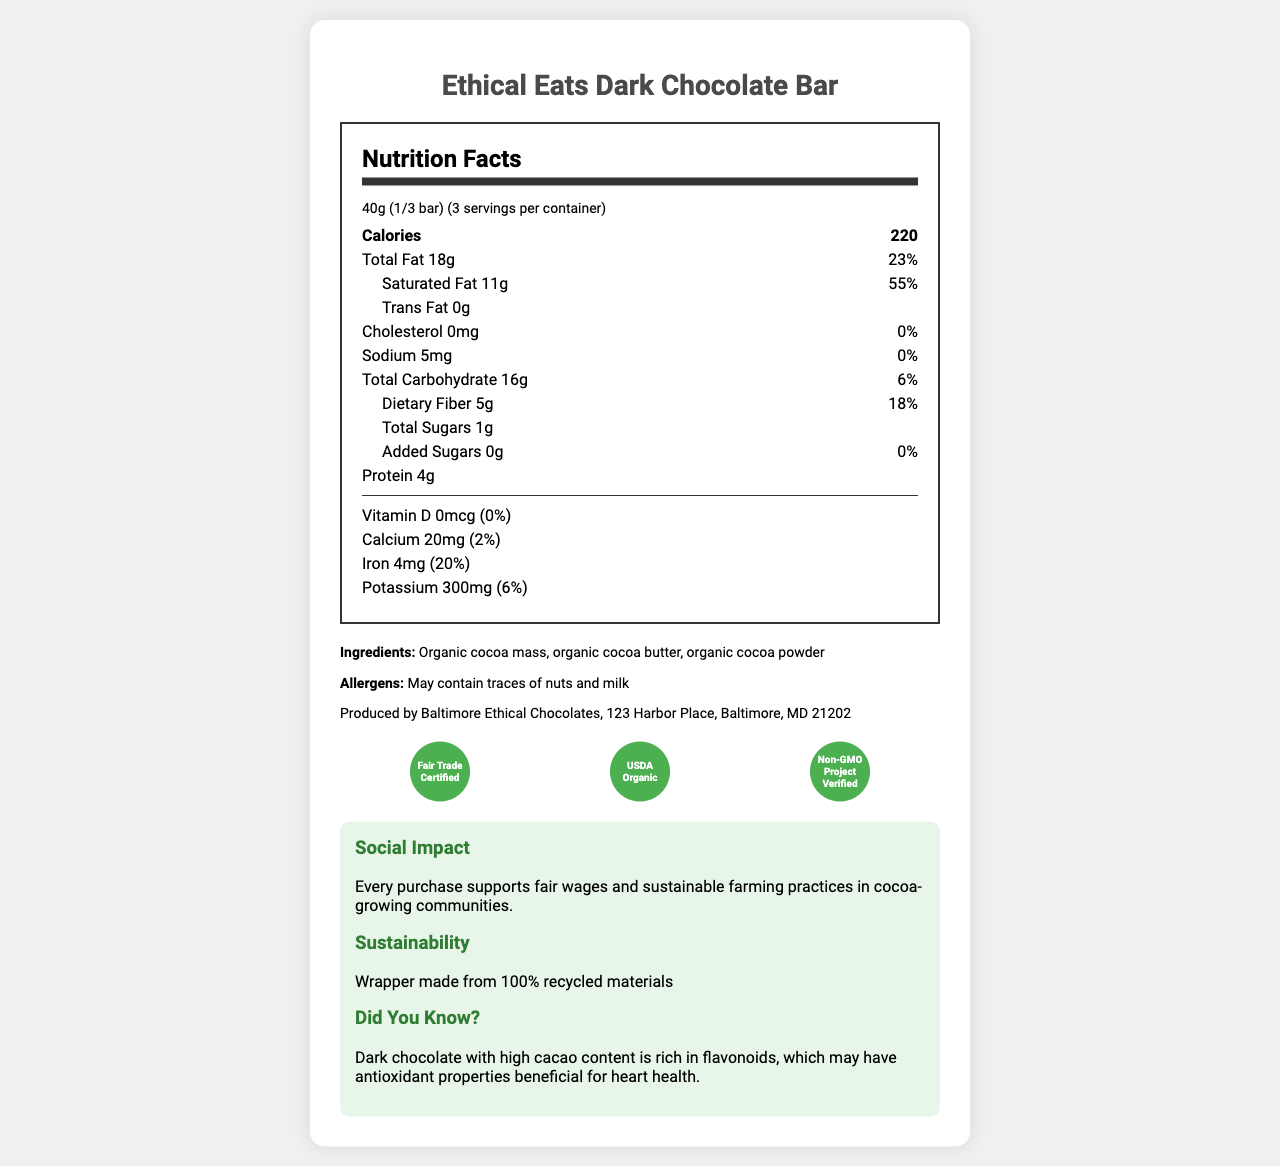what is the serving size for the Ethical Eats Dark Chocolate Bar? The serving size is specified as 40g, which is equivalent to 1/3 of the bar.
Answer: 40g (1/3 bar) how many servings are there per container? The document mentions that there are 3 servings per container.
Answer: 3 how many calories are there in one serving? The calories per serving are listed as 220.
Answer: 220 what is the percentage of daily value for saturated fat per serving? The document shows that the percentage daily value for saturated fat per serving is 55%.
Answer: 55% how much protein is in a single serving of the dark chocolate bar? The amount of protein per serving is listed as 4g.
Answer: 4g which certification does not the Ethical Eats Dark Chocolate Bar have? A. Fair Trade Certified B. USDA Organic C. Rainforest Alliance Certified D. Non-GMO Project Verified The chocolate bar does not have the Rainforest Alliance Certified certification; all other certifications mentioned are present.
Answer: C what is the sodium content per serving? A. 0mg B. 5mg C. 10mg D. 15mg The sodium content per serving is 5mg.
Answer: B does the chocolate bar contain added sugars? The document specifies that there are 0g of added sugars in the chocolate bar.
Answer: No is the wrapper of the chocolate bar made from recycled materials? The document mentions that the wrapper is made from 100% recycled materials.
Answer: Yes summarize the key nutritional information provided for the Ethical Eats Dark Chocolate Bar. This summary encapsulates all the key nutritional facts as listed in the document.
Answer: The chocolate bar has a serving size of 40g with 3 servings per container. It contains 220 calories per serving, 18g of total fat (23% DV), 11g of saturated fat (55% DV), 0g trans fat, 0mg cholesterol, 5mg sodium (0% DV), 16g of total carbohydrates (6% DV), 5g of dietary fiber (18% DV), 1g of total sugars, 0g of added sugars, and 4g of protein. Notable vitamins and minerals include 0mcg vitamin D (0% DV), 20mg calcium (2% DV), 4mg iron (20% DV), and 300mg potassium (6% DV). how much iron does the chocolate bar provide per serving? The document lists iron content as 4mg per serving, contributing 20% of the daily value.
Answer: 4mg (20%) can I find out the exact origin of cocoa used in the chocolate bar from the document? The document mentions fair trade and sustainable farming practices but does not provide exact details about the origin of the cocoa.
Answer: Cannot be determined how many grams of dietary fiber are included in each serving? The amount of dietary fiber per serving is specified as 5g.
Answer: 5g what is the main teaching idea associated with the chocolate bar? The document suggests using the chocolate bar to teach students about global trade, sustainability, and the health benefits of natural foods.
Answer: Use this chocolate bar to teach students about global trade, sustainability, and the health benefits of natural foods. which ingredient is not listed in the chocolate bar? A. Organic cocoa mass B. Organic cocoa butter C. Organic cocoa powder D. Sugar The ingredients listed are organic cocoa mass, organic cocoa butter, and organic cocoa powder; sugar is not listed as an ingredient.
Answer: D 